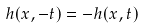<formula> <loc_0><loc_0><loc_500><loc_500>h ( x , - t ) = - h ( x , t )</formula> 